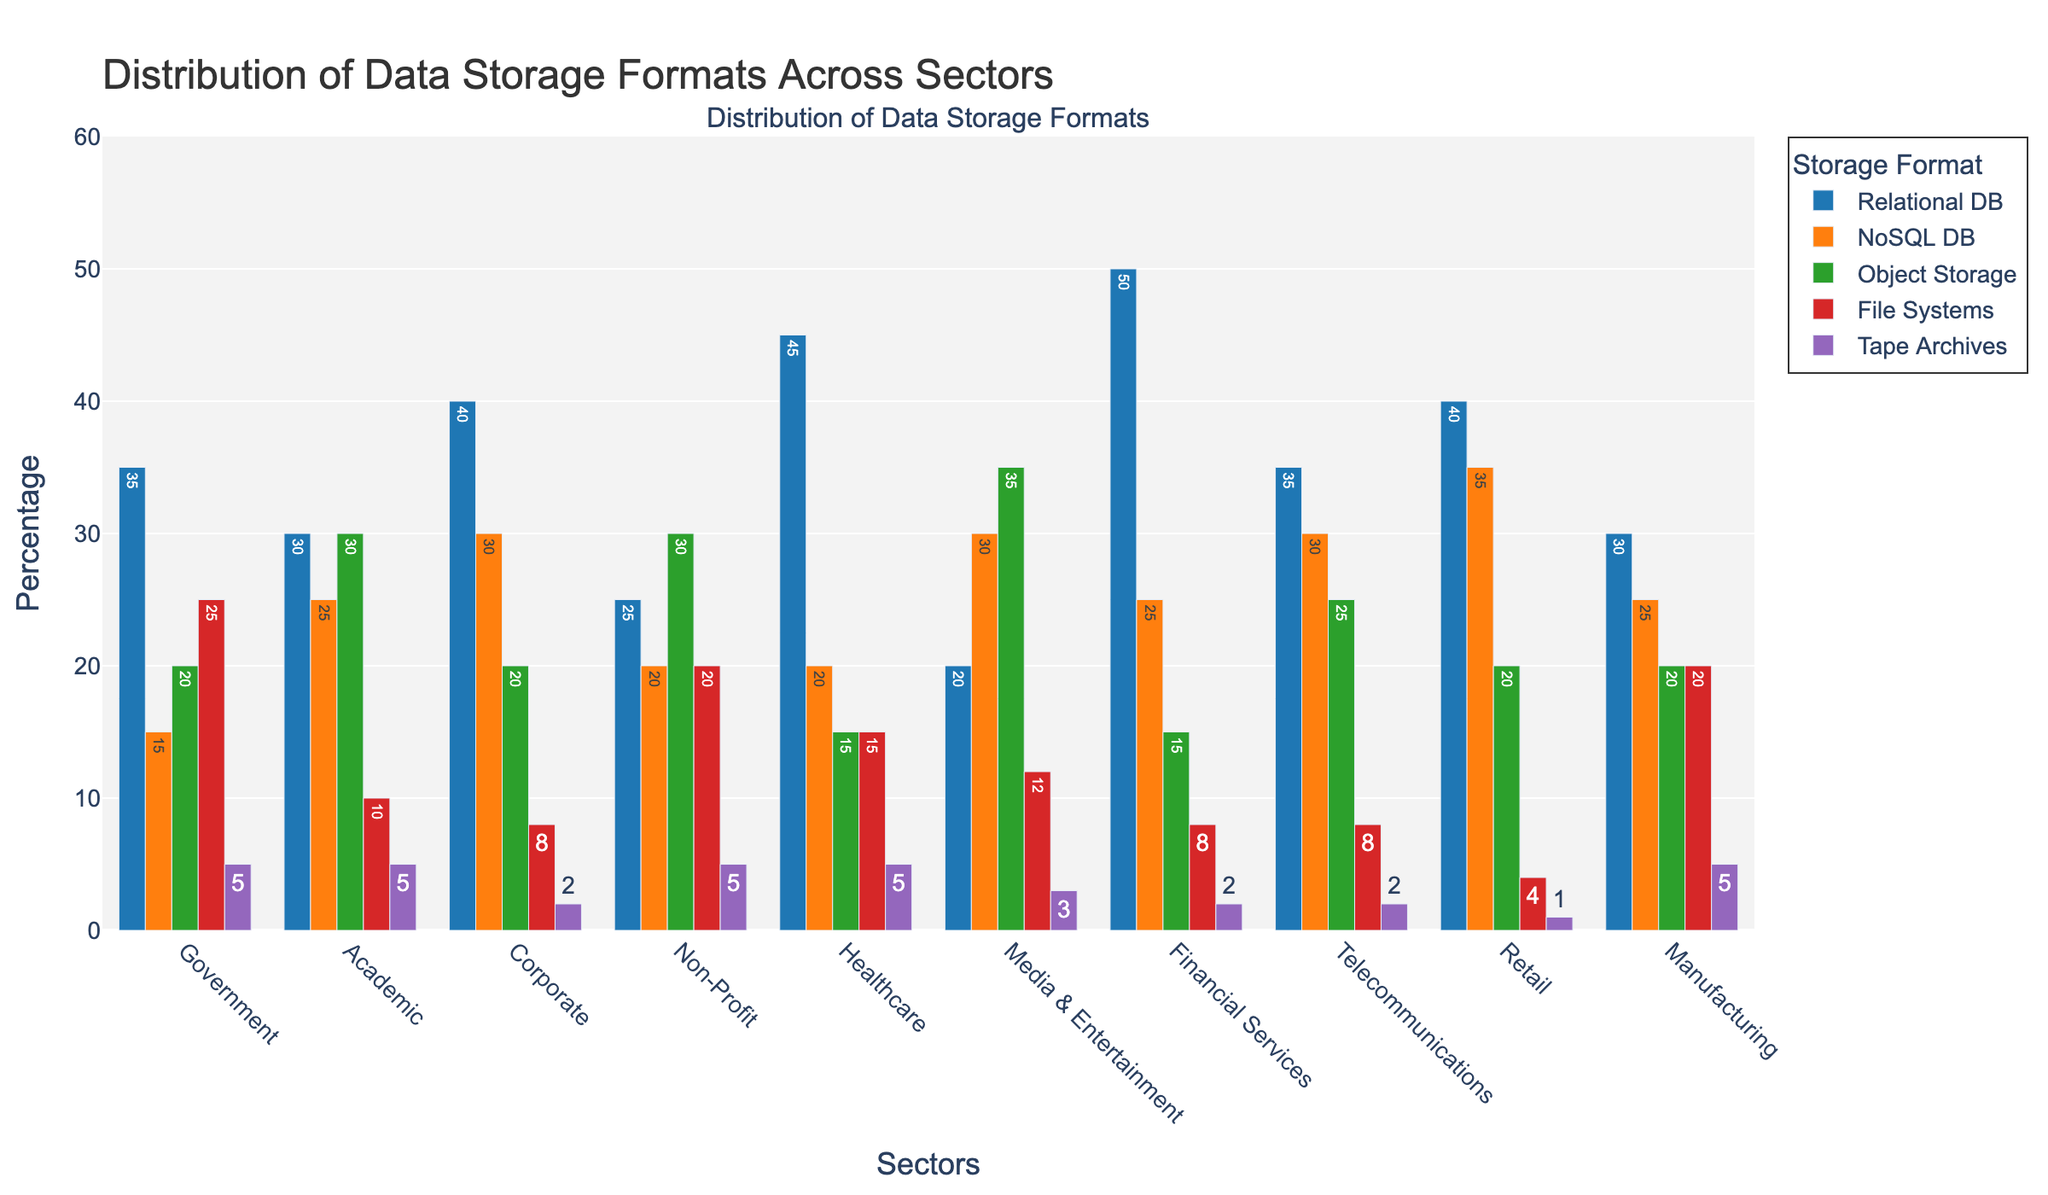what percentage of the academic sector uses NoSQL DB? Observe the bar height for NoSQL DB in the academic sector and read the value next to it, which represents the percentage.
Answer: 25 Which sector has the highest usage of File Systems for data storage? Compare the bar heights for File Systems across all sectors. The sector with the tallest bar in this category is the one with the highest usage.
Answer: Government How does the use of Relational DB in the government sector compare to its use in healthcare? Observe and compare the heights of the Relational DB bars in the government and healthcare sectors. The values next to the bars should be compared directly.
Answer: Government: 35, Healthcare: 45 What is the total percentage of Object Storage usage across all sectors? Sum the percentages of Object Storage in all sectors: Government (20) + Academic (30) + Corporate (20) + Non-Profit (30) + Healthcare (15) + Media & Entertainment (35) + Financial Services (15) + Telecommunications (25) + Retail (20) + Manufacturing (20) = 230.
Answer: 230 Which data storage format is least used in the retail sector? Identify the shortest bar in the retail sector and read the value next to it, indicating the lowest usage percentage.
Answer: Tape Archives Is the usage of NoSQL DB greater than or less than File Systems in the media & entertainment sector? Compare the bar heights for NoSQL DB and File Systems in the media & entertainment sector. The values next to the bars should be used to establish whether NoSQL DB is greater than File Systems or not.
Answer: Greater What is the average usage percentage of Relational DB across all sectors? Sum the percentages of Relational DB usage in all sectors: Government (35) + Academic (30) + Corporate (40) + Non-Profit (25) + Healthcare (45) + Media & Entertainment (20) + Financial Services (50) + Telecommunications (35) + Retail (40) + Manufacturing (30) = 350. Divide by the number of sectors (10) to get the average: 350 / 10 = 35.
Answer: 35 What is the difference in the usage of Tape Archives between corporate and manufacturing sectors? Identify the percentages of Tape Archives usage in the corporate and manufacturing sectors: Corporate (2) and Manufacturing (5). Subtract the smaller value from the larger one to find the difference: 5 - 2 = 3.
Answer: 3 Which sector has the highest overall usage of any single storage format and what is the format? Examine each sector for the highest percentage bar in any of the storage formats. Identify the sector and the corresponding storage format.
Answer: Financial Services, Relational DB (50) What is the combined percentage usage of NoSQL DB and Object Storage in the non-profit sector? Add the percentages of NoSQL DB (20) and Object Storage (30) in the non-profit sector: 20 + 30 = 50.
Answer: 50 